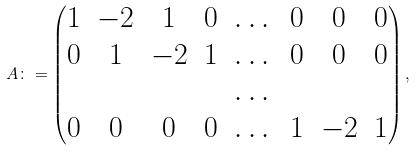Convert formula to latex. <formula><loc_0><loc_0><loc_500><loc_500>A \colon = \begin{pmatrix} 1 & - 2 & 1 & 0 & \dots & 0 & 0 & 0 \\ 0 & 1 & - 2 & 1 & \dots & 0 & 0 & 0 \\ & & & & \dots & & & \\ 0 & 0 & 0 & 0 & \dots & 1 & - 2 & 1 \end{pmatrix} ,</formula> 